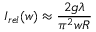<formula> <loc_0><loc_0><loc_500><loc_500>I _ { r e l } ( w ) \approx { \frac { 2 g \lambda } { \pi ^ { 2 } w R } }</formula> 